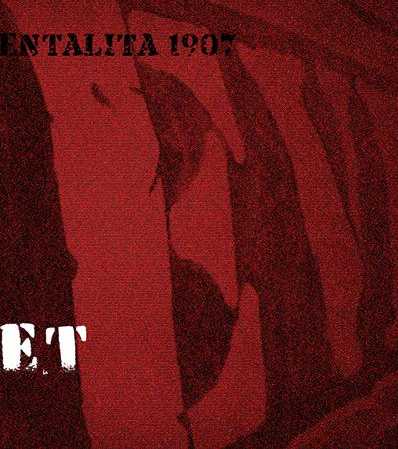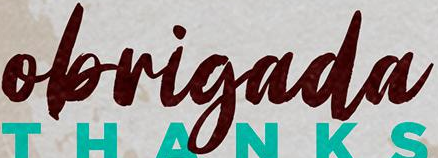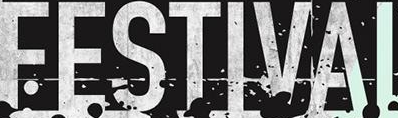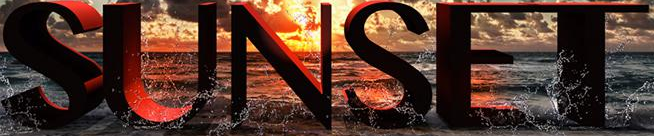What text is displayed in these images sequentially, separated by a semicolon? EV; obrigada; FESTIVAI; SUNSET 